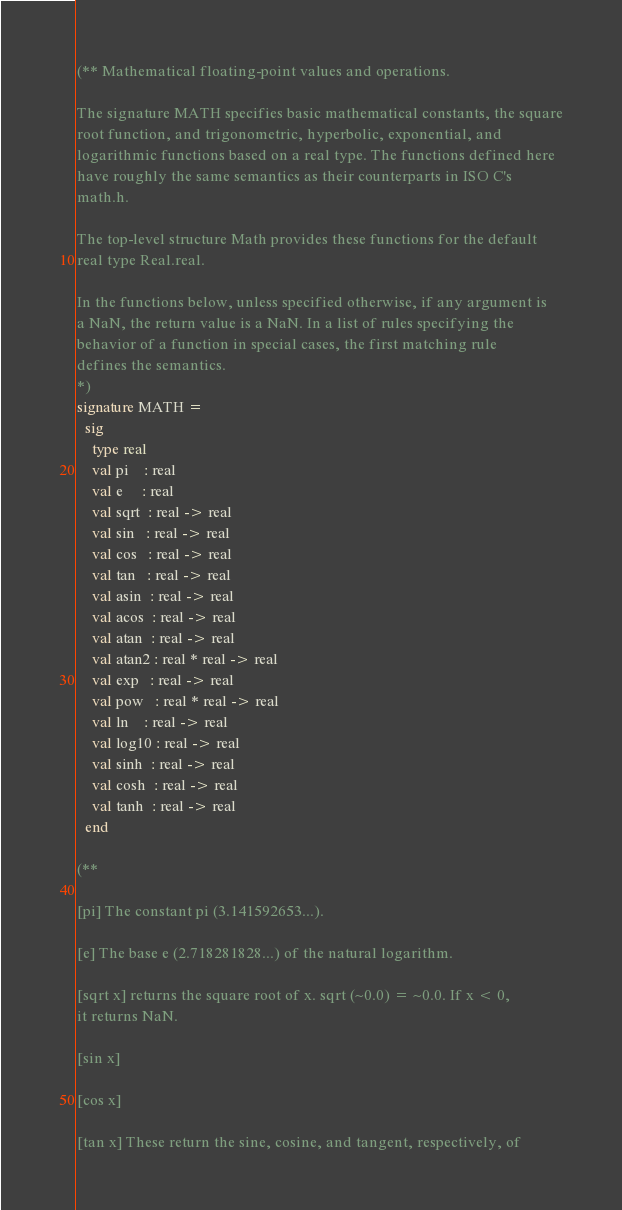Convert code to text. <code><loc_0><loc_0><loc_500><loc_500><_SML_>(** Mathematical floating-point values and operations.
 
The signature MATH specifies basic mathematical constants, the square
root function, and trigonometric, hyperbolic, exponential, and
logarithmic functions based on a real type. The functions defined here
have roughly the same semantics as their counterparts in ISO C's
math.h.

The top-level structure Math provides these functions for the default
real type Real.real.

In the functions below, unless specified otherwise, if any argument is
a NaN, the return value is a NaN. In a list of rules specifying the
behavior of a function in special cases, the first matching rule
defines the semantics.
*)
signature MATH =
  sig
    type real
    val pi    : real
    val e     : real
    val sqrt  : real -> real
    val sin   : real -> real
    val cos   : real -> real
    val tan   : real -> real
    val asin  : real -> real
    val acos  : real -> real
    val atan  : real -> real
    val atan2 : real * real -> real
    val exp   : real -> real
    val pow   : real * real -> real
    val ln    : real -> real
    val log10 : real -> real
    val sinh  : real -> real
    val cosh  : real -> real
    val tanh  : real -> real
  end

(**

[pi] The constant pi (3.141592653...).

[e] The base e (2.718281828...) of the natural logarithm.

[sqrt x] returns the square root of x. sqrt (~0.0) = ~0.0. If x < 0,
it returns NaN.

[sin x]

[cos x]

[tan x] These return the sine, cosine, and tangent, respectively, of</code> 